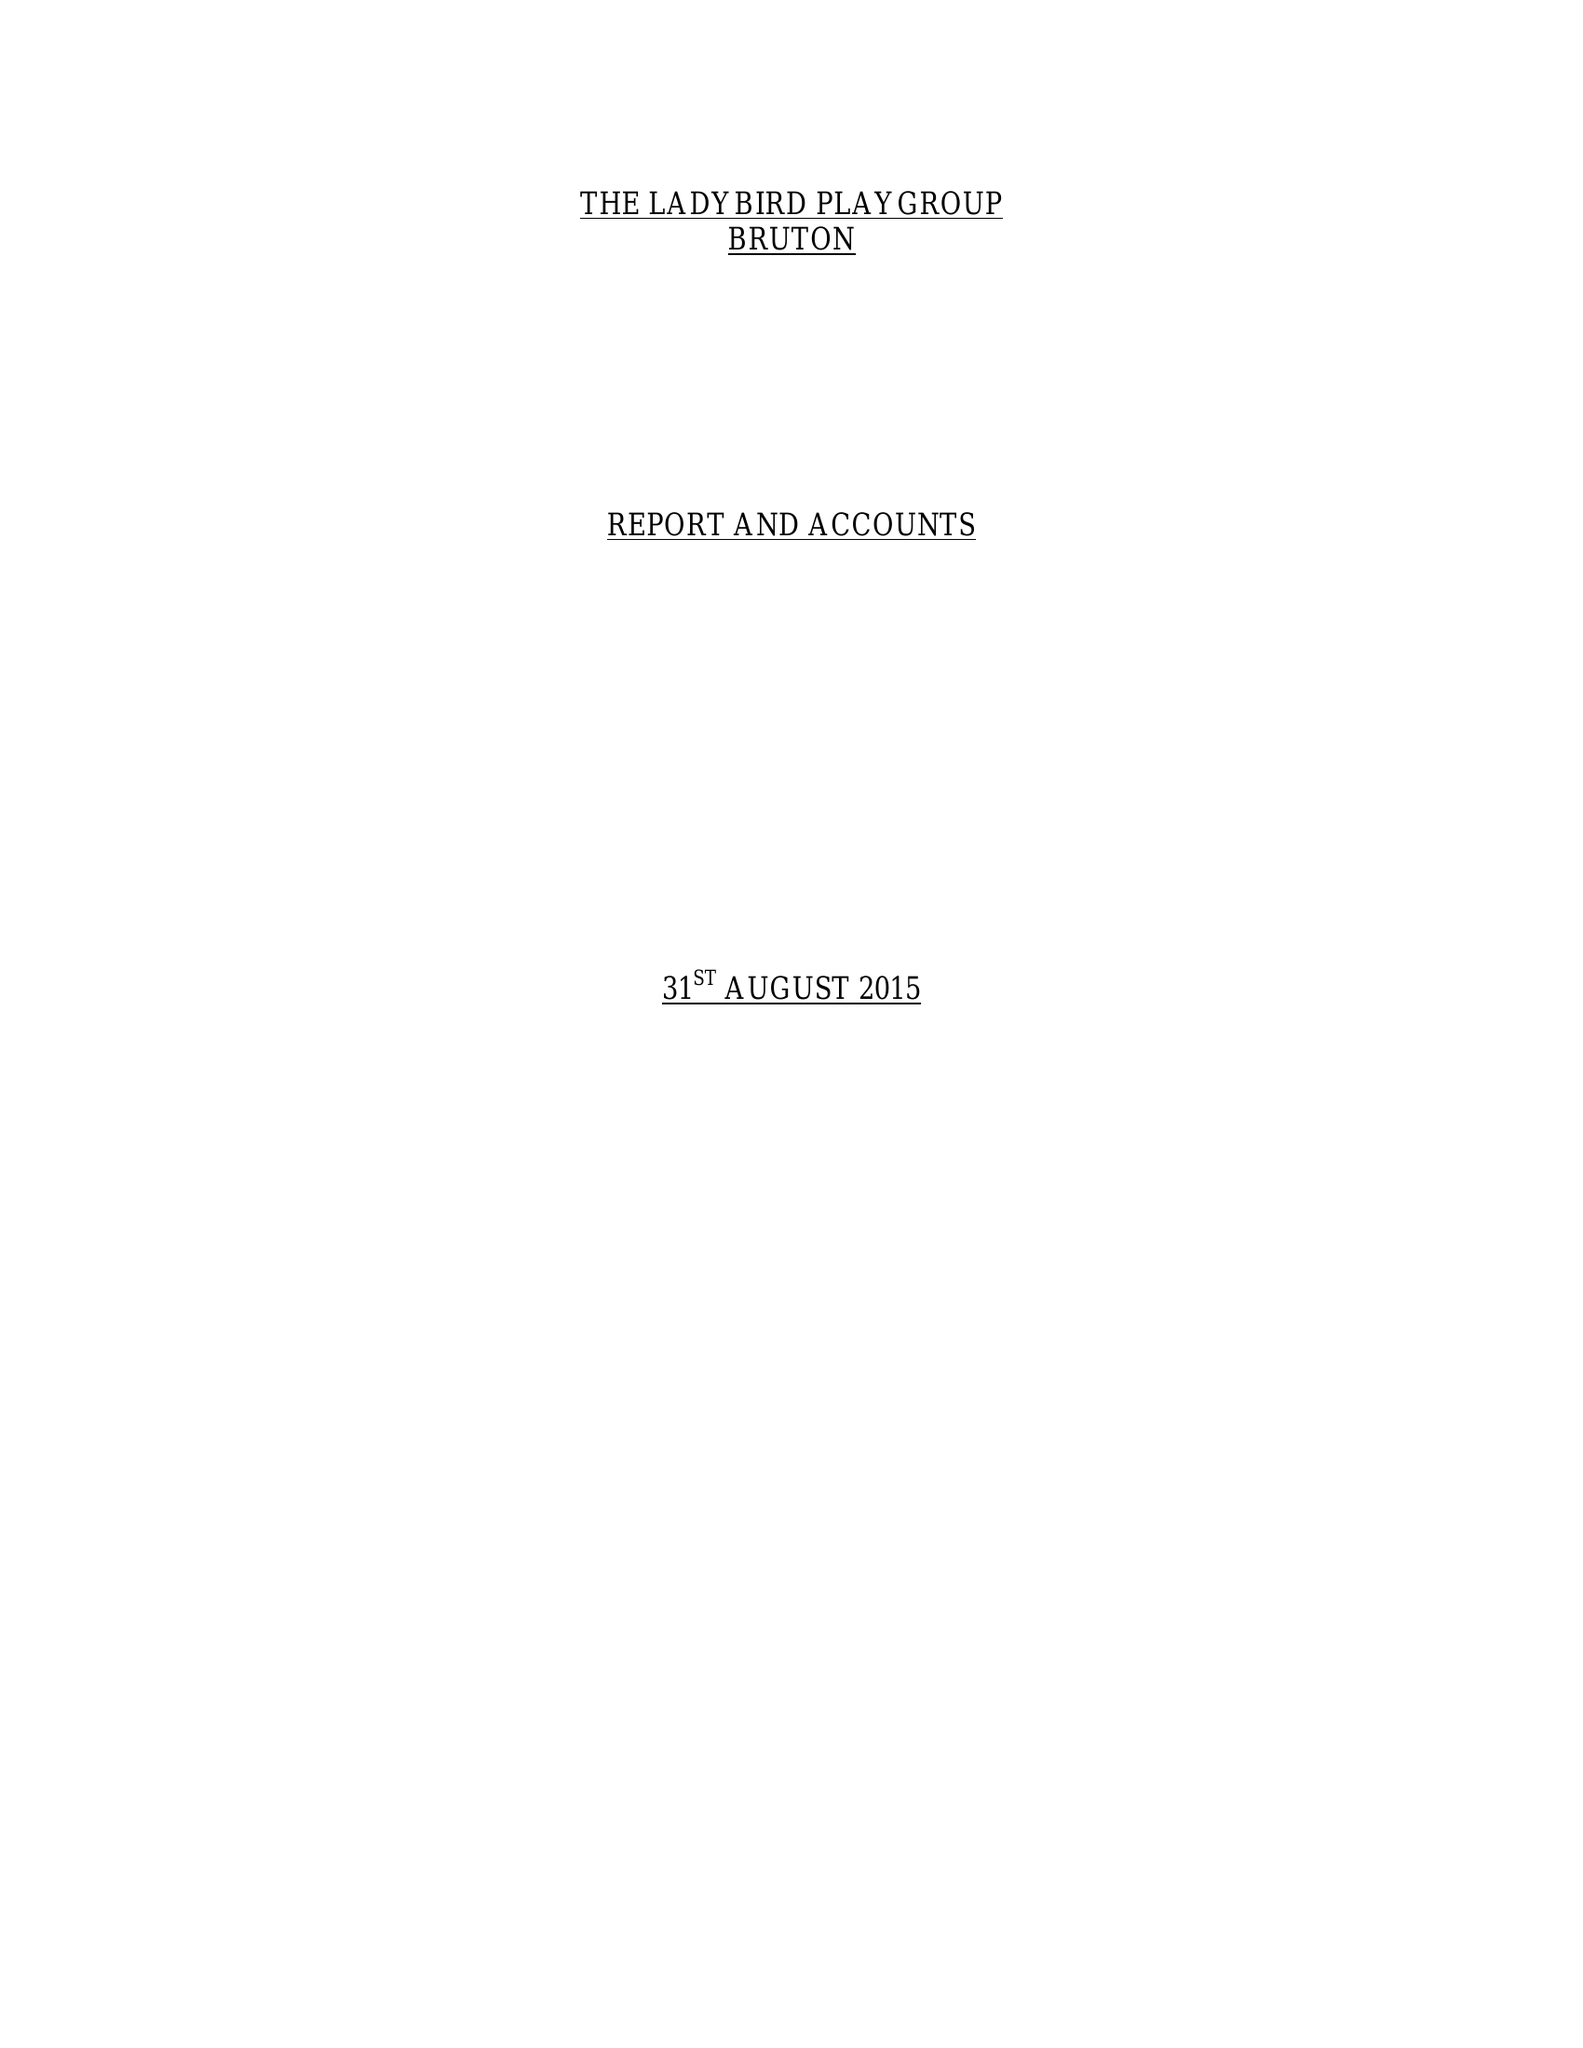What is the value for the address__postcode?
Answer the question using a single word or phrase. BA10  